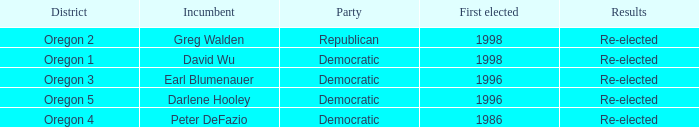Who is the incumbent for the Oregon 5 District that was elected in 1996? Darlene Hooley. 